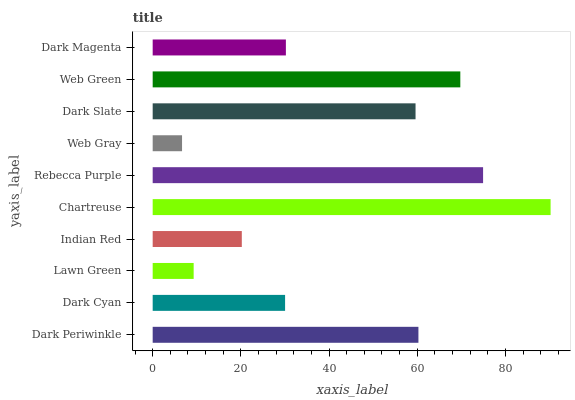Is Web Gray the minimum?
Answer yes or no. Yes. Is Chartreuse the maximum?
Answer yes or no. Yes. Is Dark Cyan the minimum?
Answer yes or no. No. Is Dark Cyan the maximum?
Answer yes or no. No. Is Dark Periwinkle greater than Dark Cyan?
Answer yes or no. Yes. Is Dark Cyan less than Dark Periwinkle?
Answer yes or no. Yes. Is Dark Cyan greater than Dark Periwinkle?
Answer yes or no. No. Is Dark Periwinkle less than Dark Cyan?
Answer yes or no. No. Is Dark Slate the high median?
Answer yes or no. Yes. Is Dark Magenta the low median?
Answer yes or no. Yes. Is Dark Magenta the high median?
Answer yes or no. No. Is Chartreuse the low median?
Answer yes or no. No. 